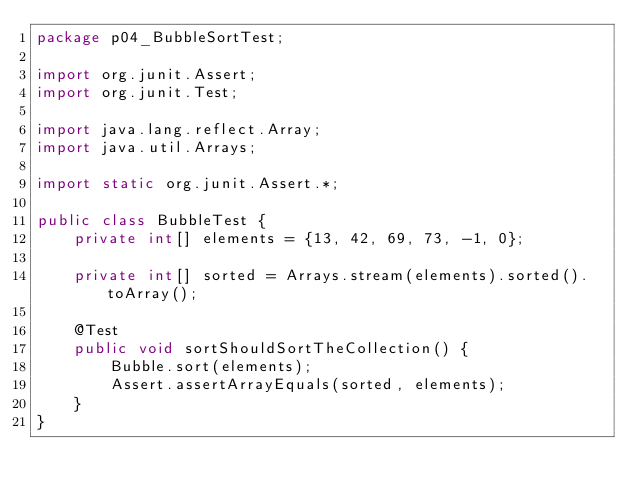<code> <loc_0><loc_0><loc_500><loc_500><_Java_>package p04_BubbleSortTest;

import org.junit.Assert;
import org.junit.Test;

import java.lang.reflect.Array;
import java.util.Arrays;

import static org.junit.Assert.*;

public class BubbleTest {
    private int[] elements = {13, 42, 69, 73, -1, 0};

    private int[] sorted = Arrays.stream(elements).sorted().toArray();

    @Test
    public void sortShouldSortTheCollection() {
        Bubble.sort(elements);
        Assert.assertArrayEquals(sorted, elements);
    }
}</code> 